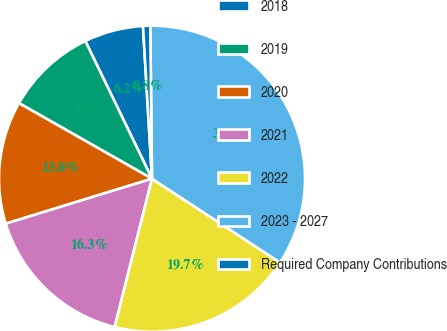Convert chart to OTSL. <chart><loc_0><loc_0><loc_500><loc_500><pie_chart><fcel>2018<fcel>2019<fcel>2020<fcel>2021<fcel>2022<fcel>2023 - 2027<fcel>Required Company Contributions<nl><fcel>6.24%<fcel>9.6%<fcel>12.97%<fcel>16.33%<fcel>19.7%<fcel>34.41%<fcel>0.76%<nl></chart> 